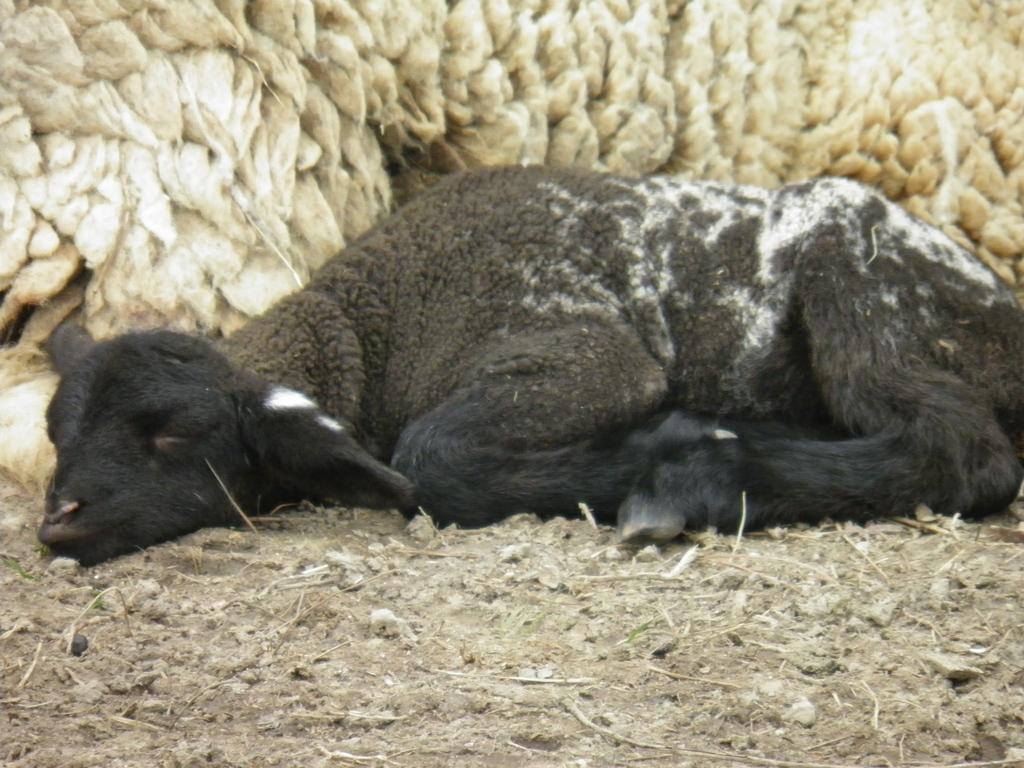Describe this image in one or two sentences. In this image we can see an animal lying on the ground. In the background, we can see fur of an animal. 